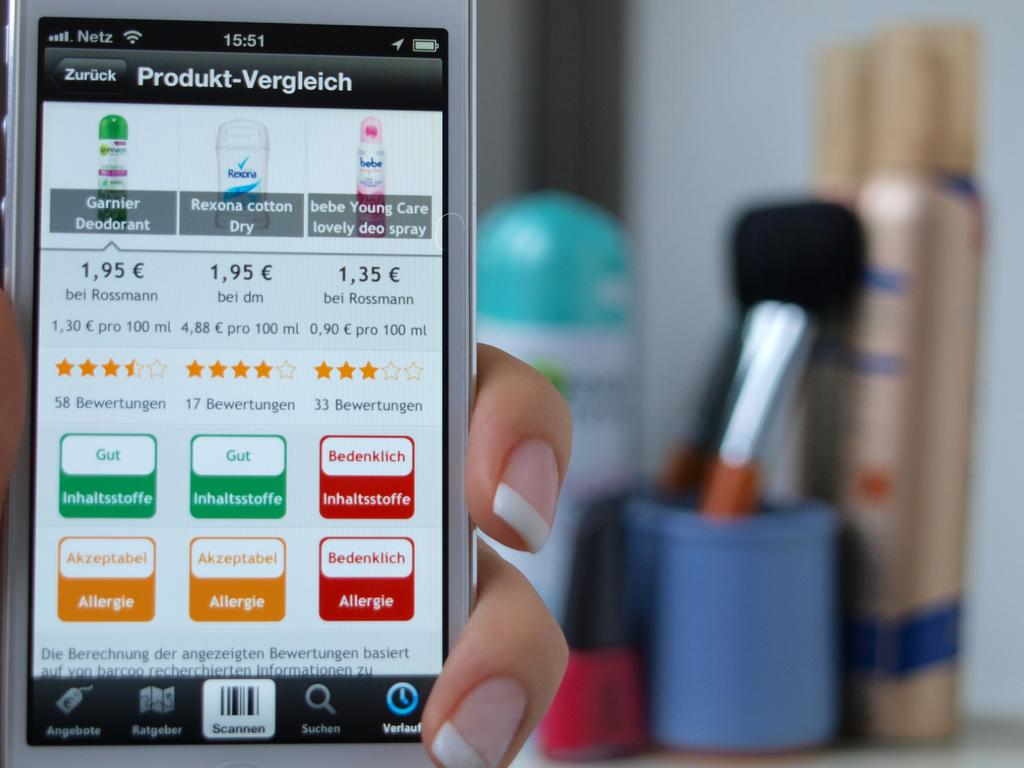<image>
Write a terse but informative summary of the picture. A phone that has a screen pulled up with various pricing and information about beauty products. 